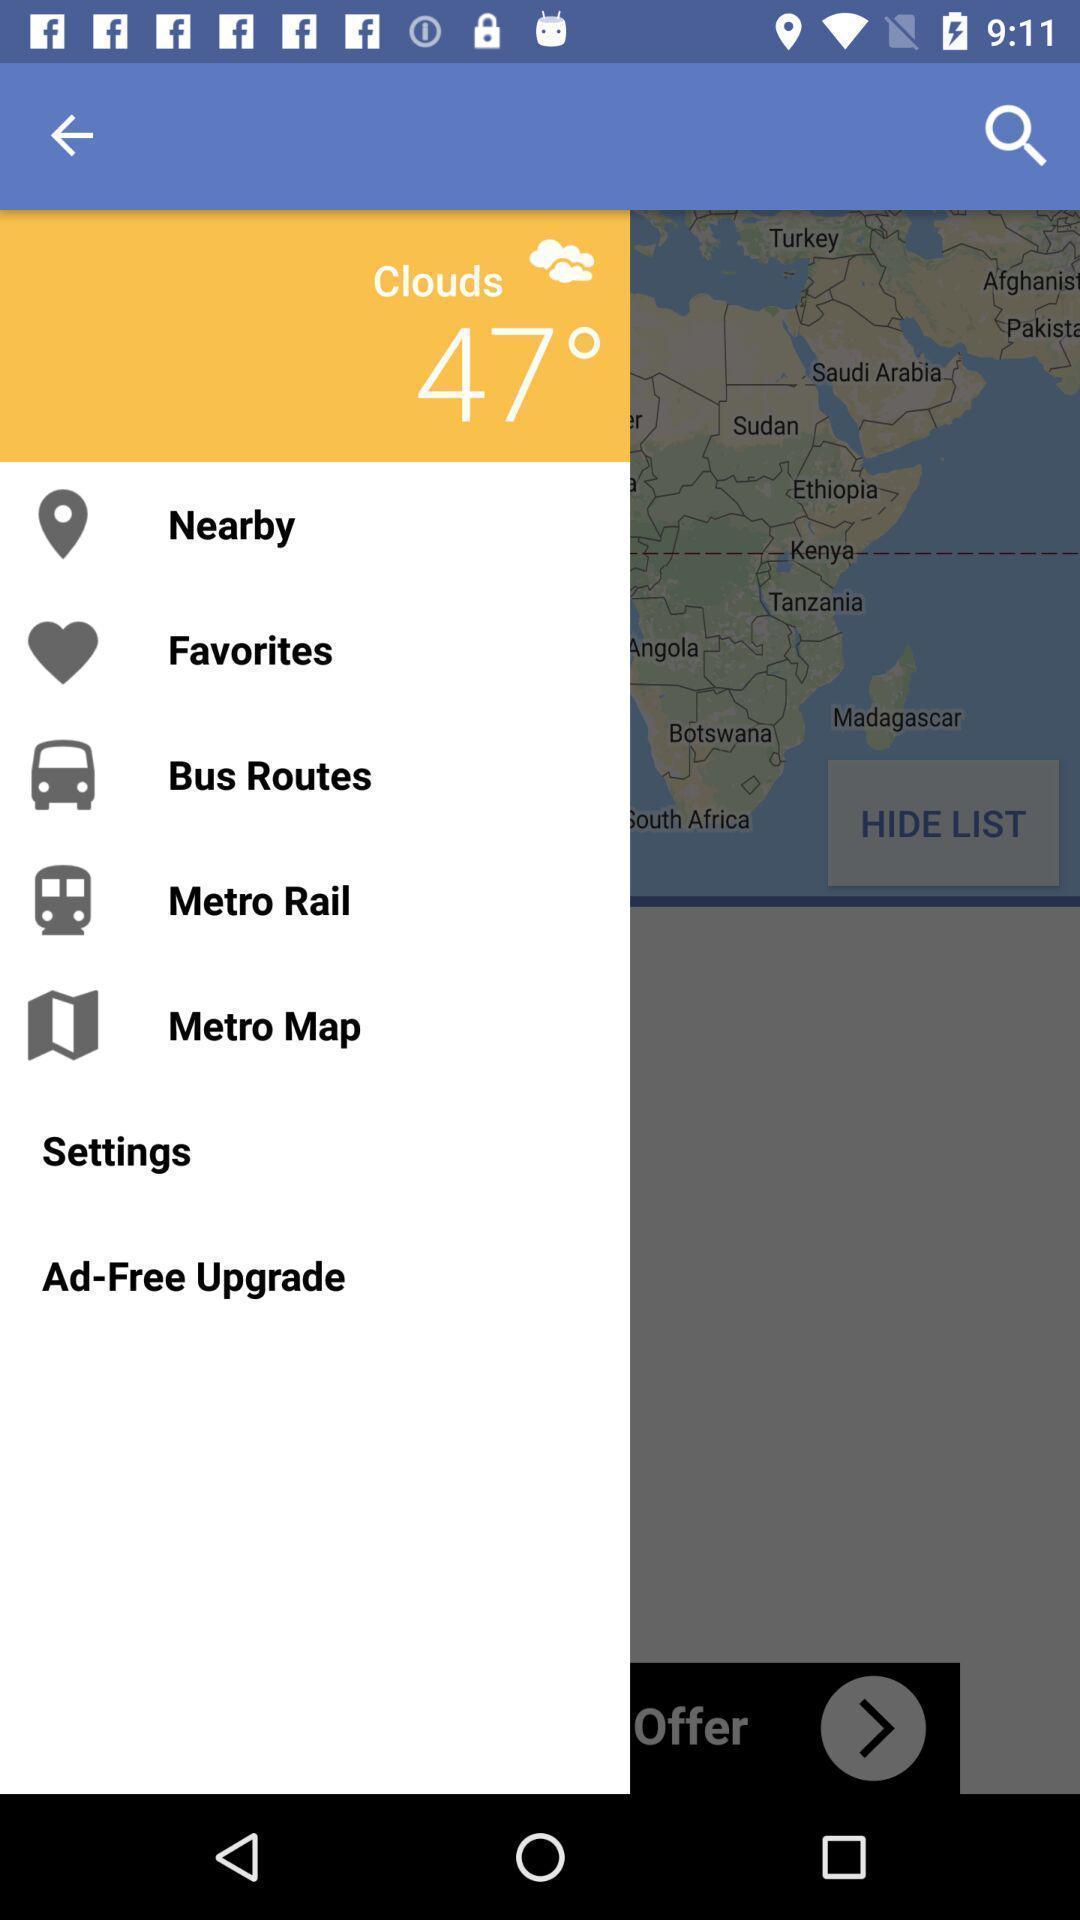What is the overall content of this screenshot? Screen display list of various options in a travel app. 